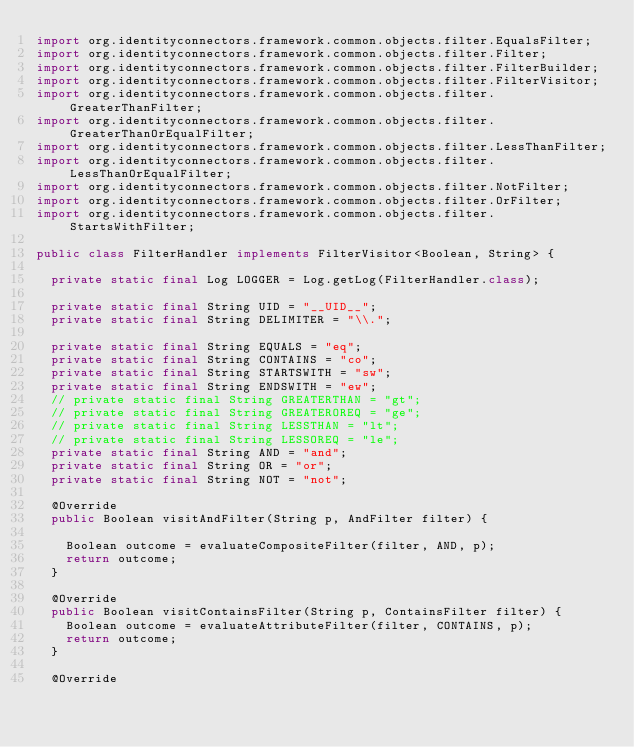Convert code to text. <code><loc_0><loc_0><loc_500><loc_500><_Java_>import org.identityconnectors.framework.common.objects.filter.EqualsFilter;
import org.identityconnectors.framework.common.objects.filter.Filter;
import org.identityconnectors.framework.common.objects.filter.FilterBuilder;
import org.identityconnectors.framework.common.objects.filter.FilterVisitor;
import org.identityconnectors.framework.common.objects.filter.GreaterThanFilter;
import org.identityconnectors.framework.common.objects.filter.GreaterThanOrEqualFilter;
import org.identityconnectors.framework.common.objects.filter.LessThanFilter;
import org.identityconnectors.framework.common.objects.filter.LessThanOrEqualFilter;
import org.identityconnectors.framework.common.objects.filter.NotFilter;
import org.identityconnectors.framework.common.objects.filter.OrFilter;
import org.identityconnectors.framework.common.objects.filter.StartsWithFilter;

public class FilterHandler implements FilterVisitor<Boolean, String> {

	private static final Log LOGGER = Log.getLog(FilterHandler.class);

	private static final String UID = "__UID__";
	private static final String DELIMITER = "\\.";

	private static final String EQUALS = "eq";
	private static final String CONTAINS = "co";
	private static final String STARTSWITH = "sw";
	private static final String ENDSWITH = "ew";
	// private static final String GREATERTHAN = "gt";
	// private static final String GREATEROREQ = "ge";
	// private static final String LESSTHAN = "lt";
	// private static final String LESSOREQ = "le";
	private static final String AND = "and";
	private static final String OR = "or";
	private static final String NOT = "not";

	@Override
	public Boolean visitAndFilter(String p, AndFilter filter) {

		Boolean outcome = evaluateCompositeFilter(filter, AND, p);
		return outcome;
	}

	@Override
	public Boolean visitContainsFilter(String p, ContainsFilter filter) {
		Boolean outcome = evaluateAttributeFilter(filter, CONTAINS, p);
		return outcome;
	}

	@Override</code> 